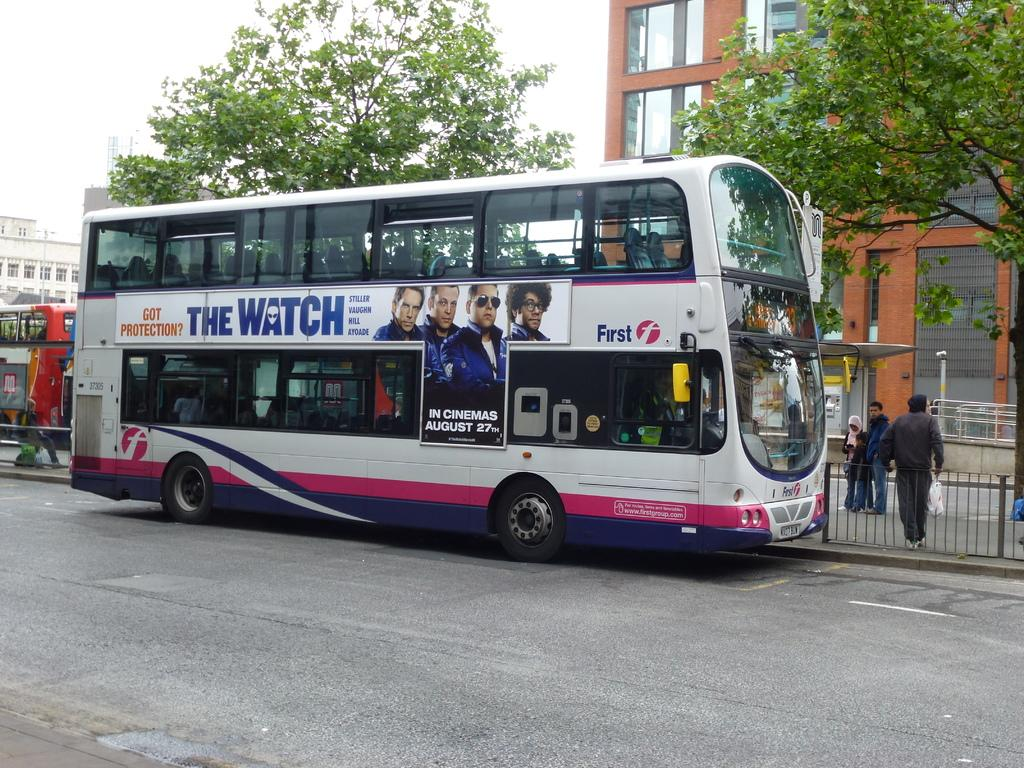What type of vehicles can be seen on the road in the image? There are two Double Decker buses on the road in the image. How many people are standing in the image? There are three persons standing in the image. What type of architectural feature is visible in the image? There are iron grills visible in the image. What structures can be seen in the image? There are buildings in the image. What type of vegetation is present in the image? There are trees in the image. What is visible in the background of the image? The sky is visible in the background of the image. What type of juice is being served to the ants in the image? There are no ants or juice present in the image. How does the earthquake affect the buildings in the image? There is no earthquake present in the image, so its effects on the buildings cannot be determined. 